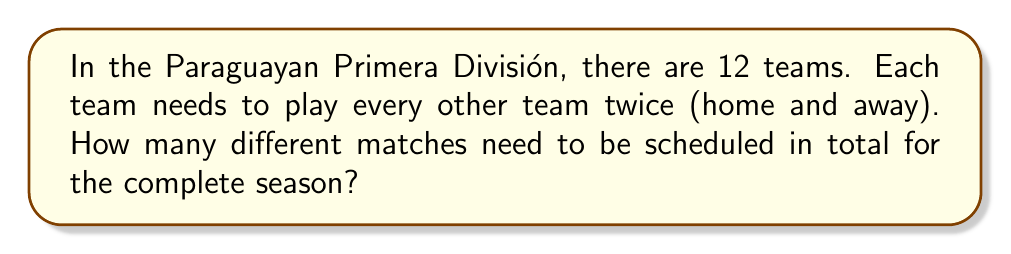Solve this math problem. Let's approach this step-by-step:

1) First, we need to calculate how many unique pairs of teams can be formed. This is a combination problem, as the order doesn't matter (Team A vs Team B is the same match as Team B vs Team A). We use the combination formula:

   $$\binom{12}{2} = \frac{12!}{2!(12-2)!} = \frac{12 \cdot 11}{2} = 66$$

2) This gives us the number of unique matches if each team played every other team once.

3) However, in this league, each team plays every other team twice (home and away). So we need to double our result:

   $$66 \cdot 2 = 132$$

Therefore, 132 matches need to be scheduled for the complete season.
Answer: 132 matches 